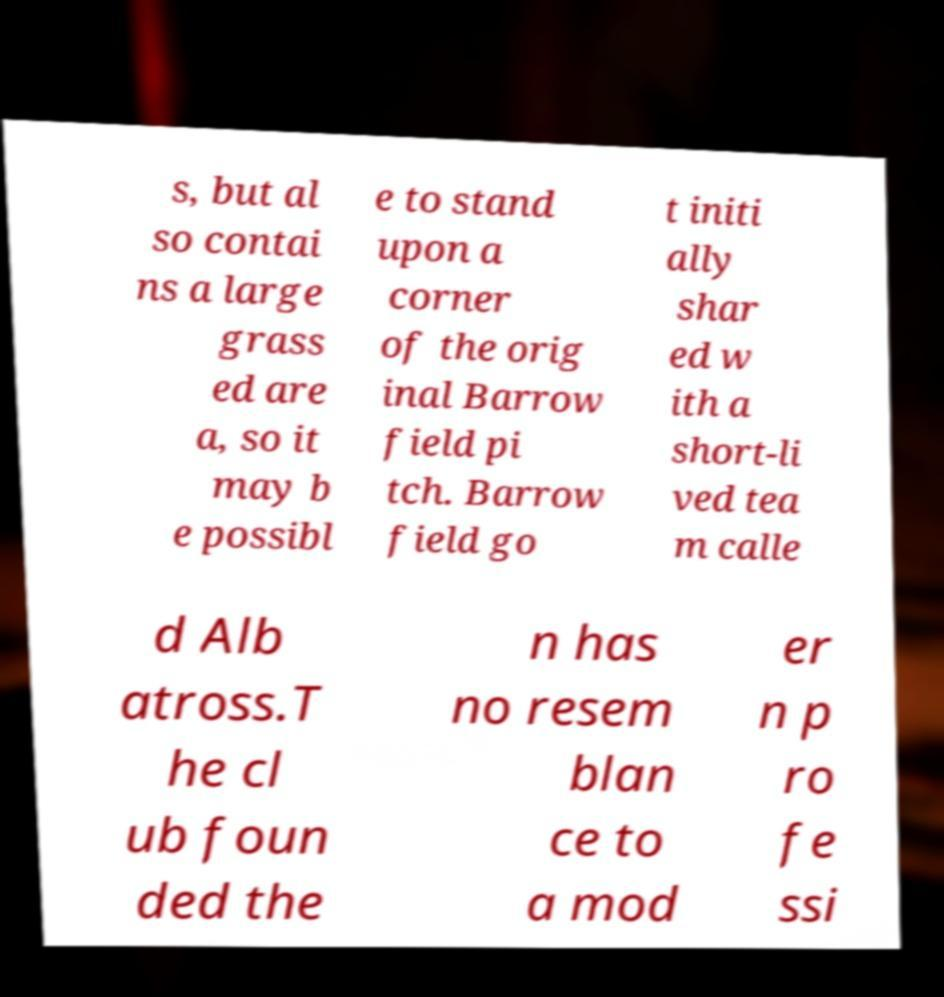Please identify and transcribe the text found in this image. s, but al so contai ns a large grass ed are a, so it may b e possibl e to stand upon a corner of the orig inal Barrow field pi tch. Barrow field go t initi ally shar ed w ith a short-li ved tea m calle d Alb atross.T he cl ub foun ded the n has no resem blan ce to a mod er n p ro fe ssi 